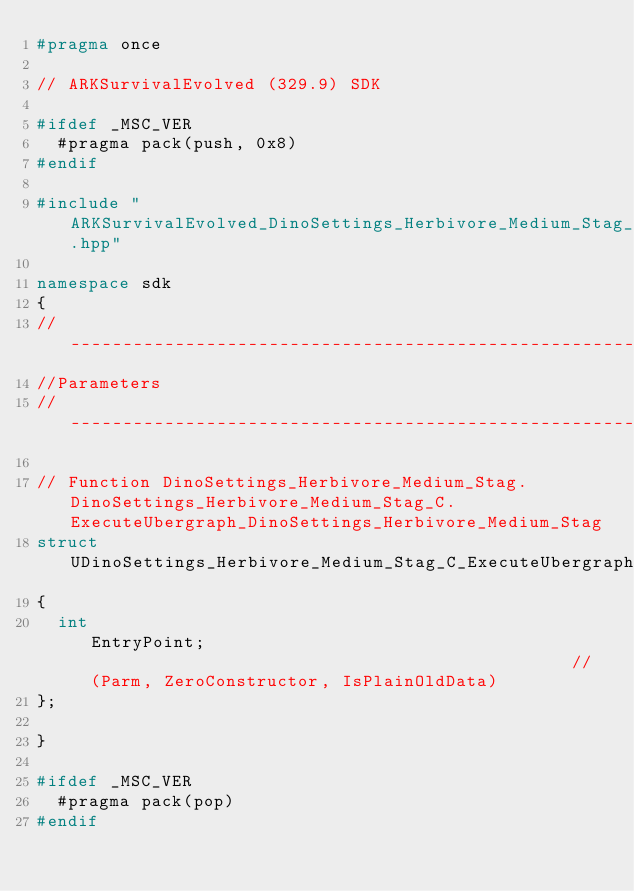<code> <loc_0><loc_0><loc_500><loc_500><_C++_>#pragma once

// ARKSurvivalEvolved (329.9) SDK

#ifdef _MSC_VER
	#pragma pack(push, 0x8)
#endif

#include "ARKSurvivalEvolved_DinoSettings_Herbivore_Medium_Stag_classes.hpp"

namespace sdk
{
//---------------------------------------------------------------------------
//Parameters
//---------------------------------------------------------------------------

// Function DinoSettings_Herbivore_Medium_Stag.DinoSettings_Herbivore_Medium_Stag_C.ExecuteUbergraph_DinoSettings_Herbivore_Medium_Stag
struct UDinoSettings_Herbivore_Medium_Stag_C_ExecuteUbergraph_DinoSettings_Herbivore_Medium_Stag_Params
{
	int                                                EntryPoint;                                               // (Parm, ZeroConstructor, IsPlainOldData)
};

}

#ifdef _MSC_VER
	#pragma pack(pop)
#endif
</code> 